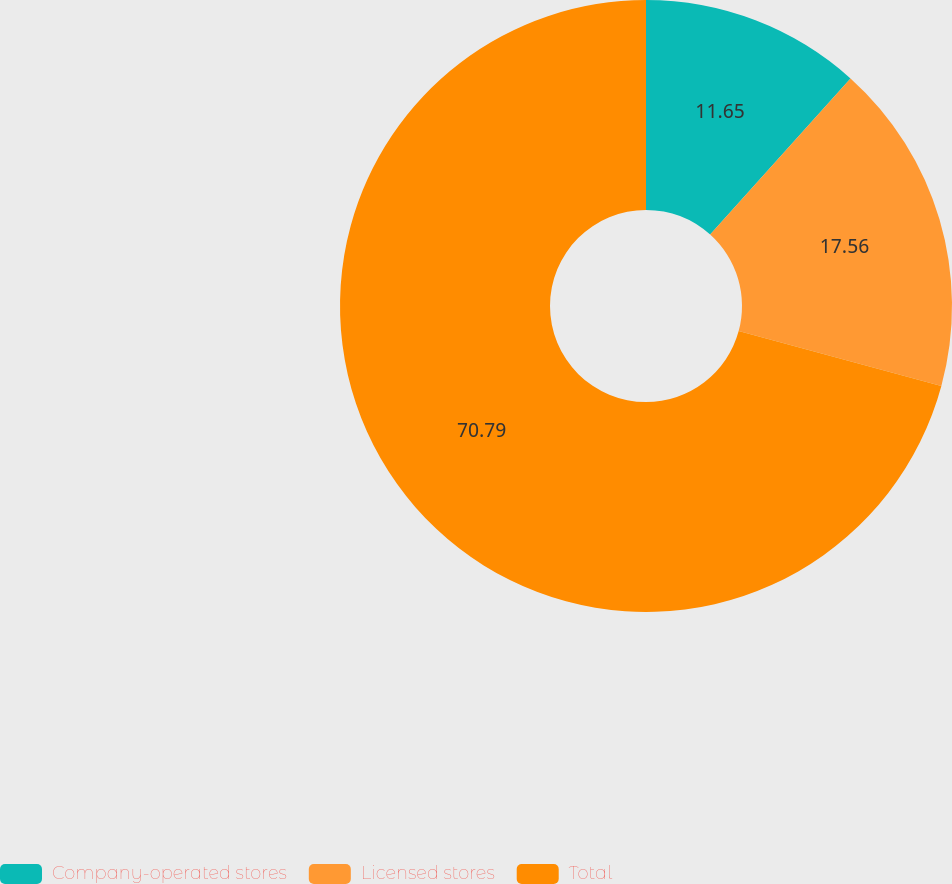Convert chart to OTSL. <chart><loc_0><loc_0><loc_500><loc_500><pie_chart><fcel>Company-operated stores<fcel>Licensed stores<fcel>Total<nl><fcel>11.65%<fcel>17.56%<fcel>70.79%<nl></chart> 